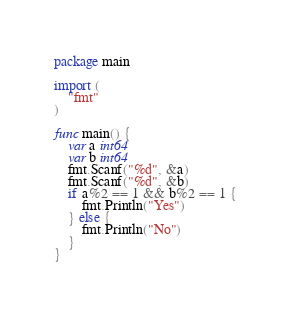Convert code to text. <code><loc_0><loc_0><loc_500><loc_500><_Go_>package main

import (
	"fmt"
)

func main() {
	var a int64
	var b int64
	fmt.Scanf("%d", &a)
	fmt.Scanf("%d", &b)
	if a%2 == 1 && b%2 == 1 {
		fmt.Println("Yes")
	} else {
		fmt.Println("No")
	}
}
</code> 